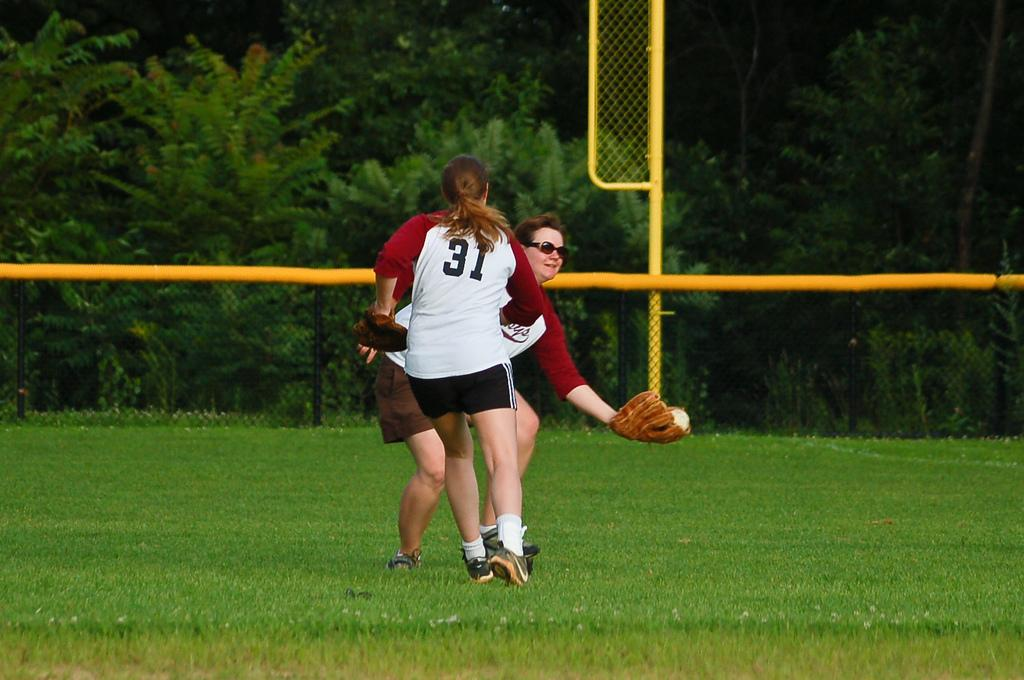Provide a one-sentence caption for the provided image. 2 women in maroon and white jerseys play softball, number 31 runs toward the lady catching the ball. 